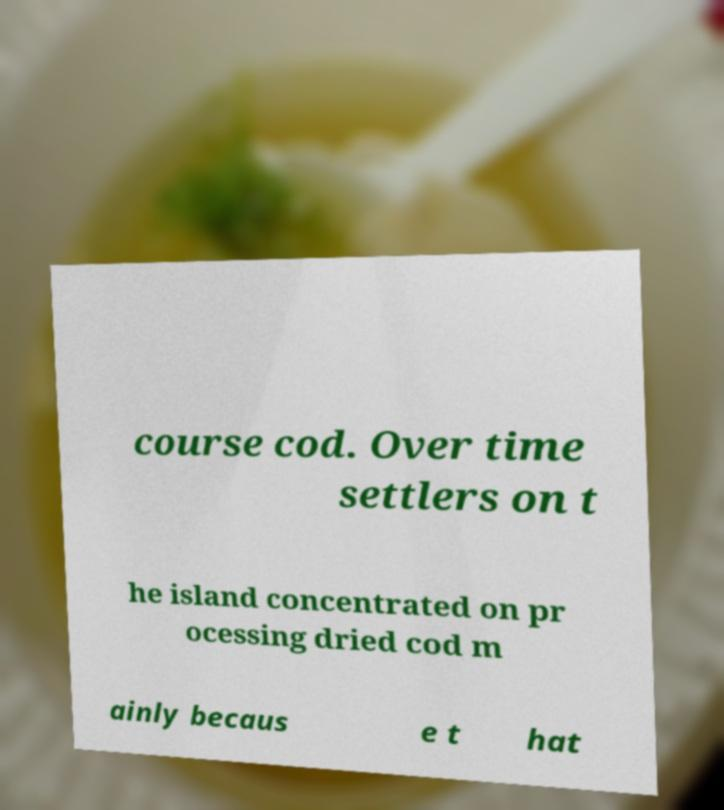Could you extract and type out the text from this image? course cod. Over time settlers on t he island concentrated on pr ocessing dried cod m ainly becaus e t hat 